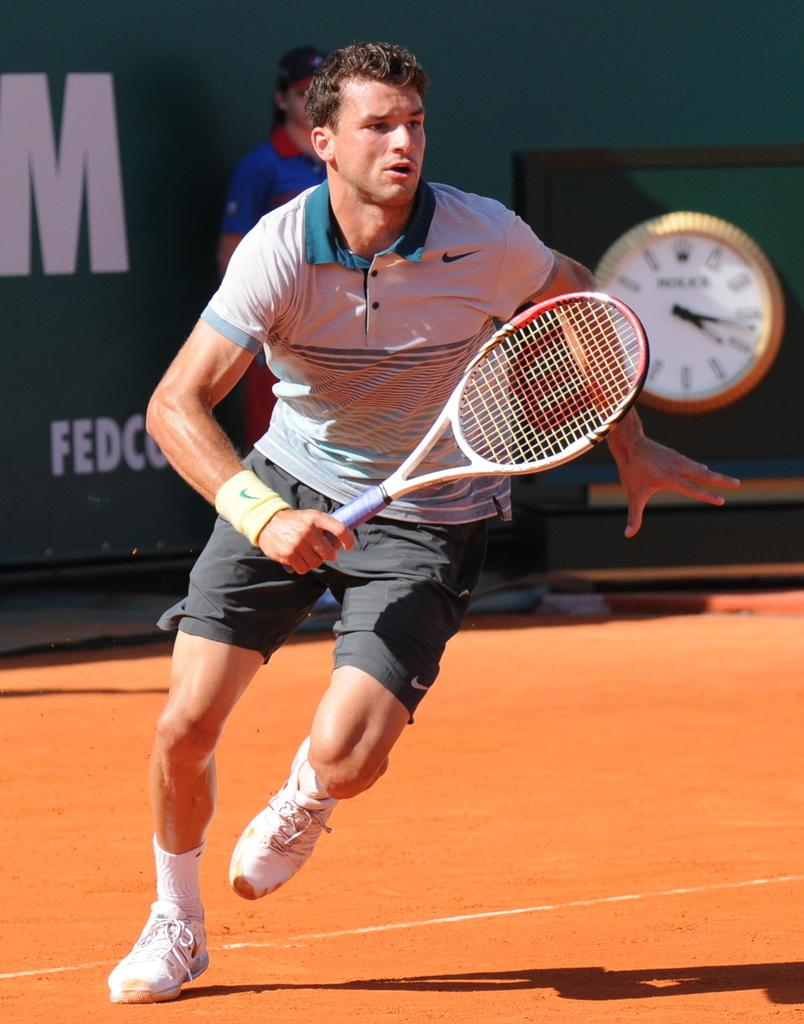What is the main subject of the image? There is a man in the image. What is the man doing in the image? The man is in motion, and he is holding a racket. Who else is present in the image? There is a woman standing in the image. What object can be used to tell time in the image? A clock is present in the image. What type of harmony is the man playing on the racket in the image? There is no musical instrument or harmony present in the image; the man is holding a racket, which is typically used for sports like tennis or badminton. 